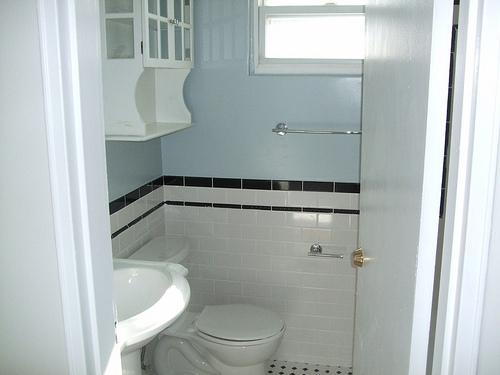How many windows are in the room?
Write a very short answer. 1. How many different tiles are used in decorating this room?
Short answer required. 3. What room is this?
Keep it brief. Bathroom. 